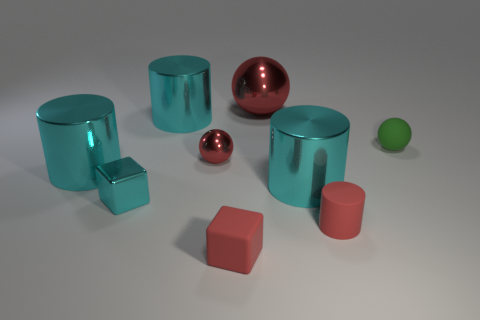Subtract all blue blocks. How many cyan cylinders are left? 3 Add 1 cyan shiny cylinders. How many objects exist? 10 Subtract all cubes. How many objects are left? 7 Subtract all green rubber balls. Subtract all big gray blocks. How many objects are left? 8 Add 5 tiny matte things. How many tiny matte things are left? 8 Add 9 large brown spheres. How many large brown spheres exist? 9 Subtract 0 blue balls. How many objects are left? 9 